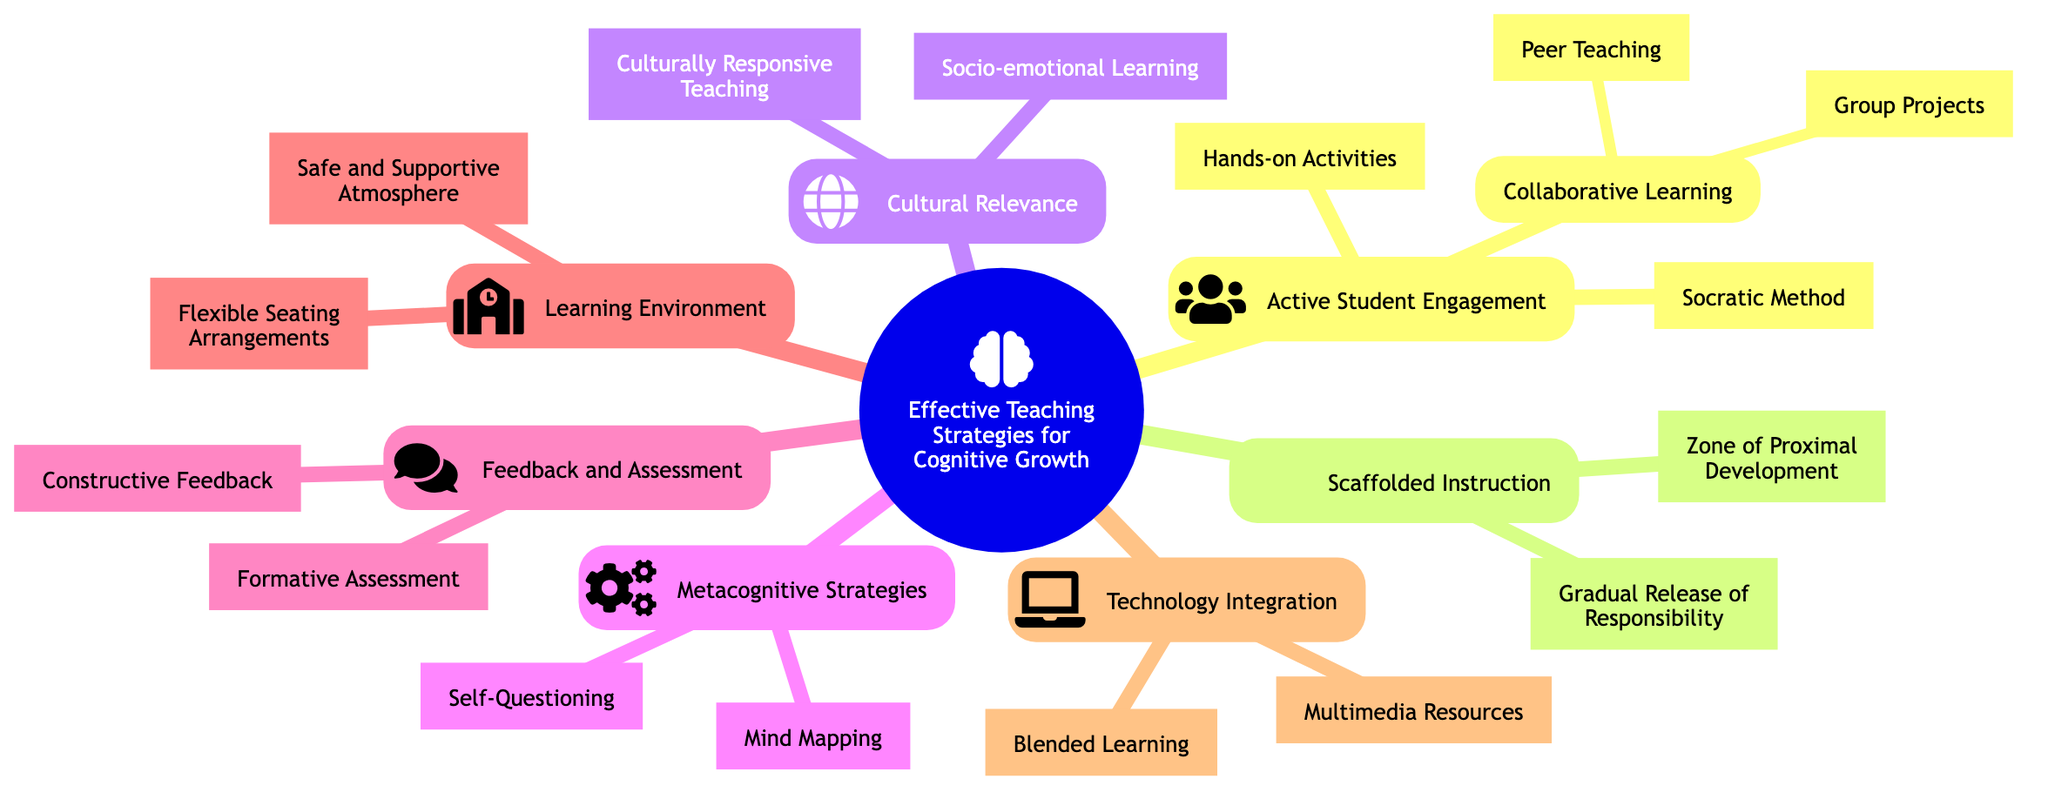What is the first main branch of the mind map? The mind map starts with the main topic "Effective Teaching Strategies for Cognitive Growth," which is the root node. Therefore, the top-level node represents the overall theme of the diagram.
Answer: Effective Teaching Strategies for Cognitive Growth How many branches are there under Active Student Engagement? Under "Active Student Engagement," there are three distinct branches: "Socratic Method," "Hands-on Activities," and "Collaborative Learning." This indicates a focus on various engagement strategies.
Answer: 3 Which teaching strategy promotes critical thinking? The "Socratic Method" is specifically highlighted in the diagram as a strategy that promotes critical thinking and active dialogue among students.
Answer: Socratic Method What is the focus of Scaffolded Instruction? Scaffolded Instruction is centered around the "Zone of Proximal Development," indicating that it emphasizes teaching within the optimal challenge level for effective learning.
Answer: Zone of Proximal Development Which category includes Culturally Responsive Teaching? The category "Cultural Relevance" encompasses "Culturally Responsive Teaching," which integrates students' cultural backgrounds into the curriculum, thereby addressing diversity in learning.
Answer: Cultural Relevance How many nodes are in the Technology Integration section? The Technology Integration section features two nodes: "Multimedia Resources" and "Blended Learning," illustrating methods to incorporate technology into teaching.
Answer: 2 What role does Flexible Seating Arrangements play in the Learning Environment? "Flexible Seating Arrangements" allows for different learning preferences and emphasizes collaboration amongst students, reflecting the importance of adaptability in teaching spaces.
Answer: Supports different learning preferences and collaboration Which method focuses on ongoing checks for understanding? "Formative Assessment" is the method identified in the diagram that focuses on providing ongoing checks for understanding during the learning process, allowing for timely insights.
Answer: Formative Assessment What is an example of a metacognitive strategy listed in the mind map? "Self-Questioning" is an example of a metacognitive strategy included in the mind map, encouraging students to reflect on their own thought processes.
Answer: Self-Questioning 